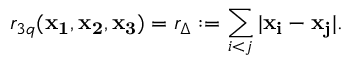Convert formula to latex. <formula><loc_0><loc_0><loc_500><loc_500>r _ { 3 q } ( { x _ { 1 } } , { x _ { 2 } } , { x _ { 3 } } ) = r _ { \Delta } \colon = \sum _ { i < j } | { x _ { i } } - { x _ { j } } | .</formula> 